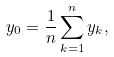Convert formula to latex. <formula><loc_0><loc_0><loc_500><loc_500>y _ { 0 } = \frac { 1 } { n } \sum _ { k = 1 } ^ { n } y _ { k } ,</formula> 